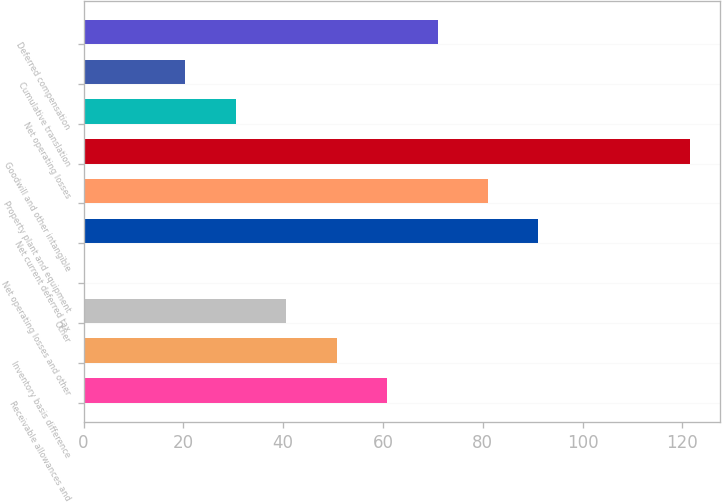<chart> <loc_0><loc_0><loc_500><loc_500><bar_chart><fcel>Receivable allowances and<fcel>Inventory basis difference<fcel>Other<fcel>Net operating losses and other<fcel>Net current deferred tax<fcel>Property plant and equipment<fcel>Goodwill and other intangible<fcel>Net operating losses<fcel>Cumulative translation<fcel>Deferred compensation<nl><fcel>60.82<fcel>50.7<fcel>40.58<fcel>0.1<fcel>91.18<fcel>81.06<fcel>121.54<fcel>30.46<fcel>20.34<fcel>70.94<nl></chart> 